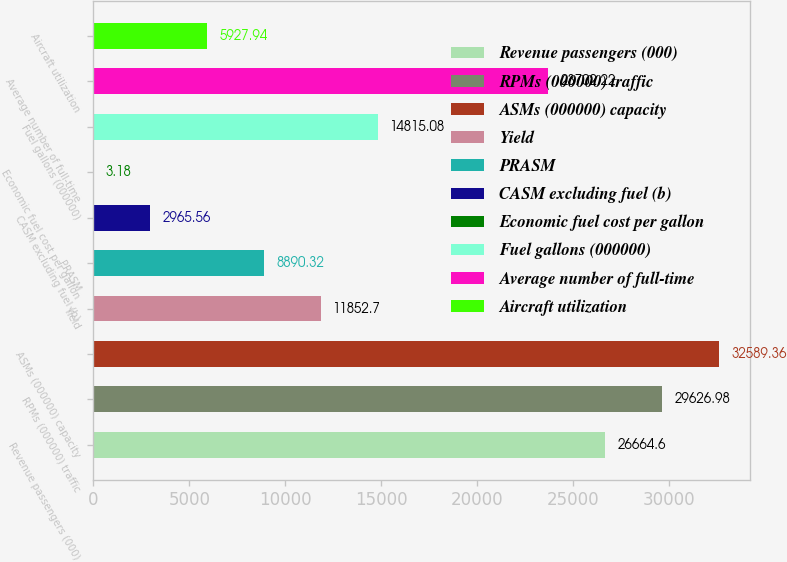Convert chart. <chart><loc_0><loc_0><loc_500><loc_500><bar_chart><fcel>Revenue passengers (000)<fcel>RPMs (000000) traffic<fcel>ASMs (000000) capacity<fcel>Yield<fcel>PRASM<fcel>CASM excluding fuel (b)<fcel>Economic fuel cost per gallon<fcel>Fuel gallons (000000)<fcel>Average number of full-time<fcel>Aircraft utilization<nl><fcel>26664.6<fcel>29627<fcel>32589.4<fcel>11852.7<fcel>8890.32<fcel>2965.56<fcel>3.18<fcel>14815.1<fcel>23702.2<fcel>5927.94<nl></chart> 